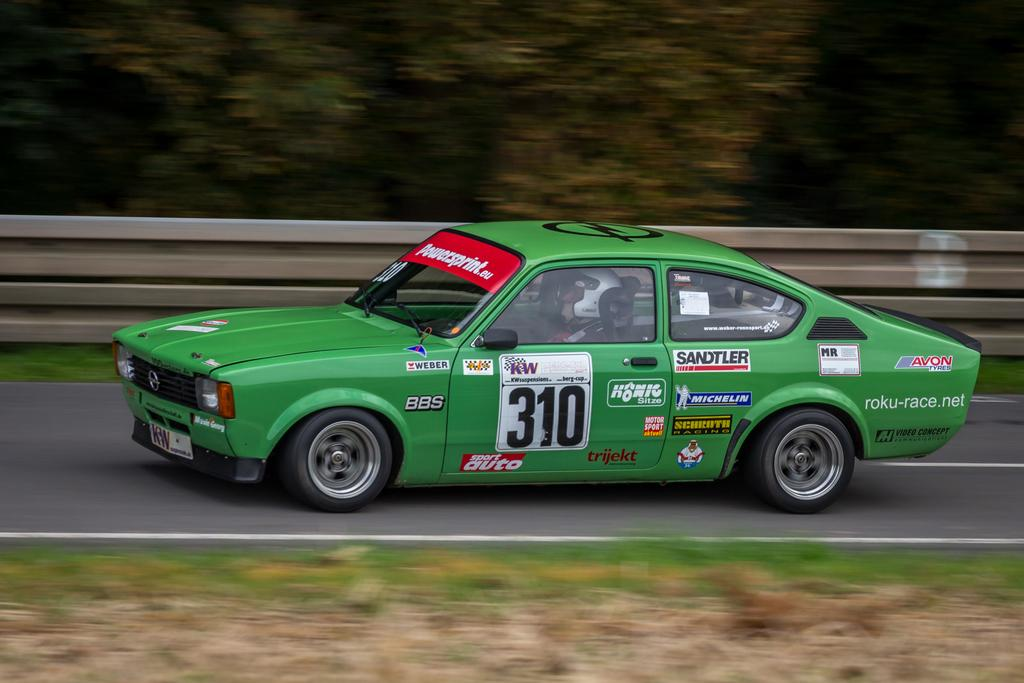What color is the car in the image? The car in the image is green. What is the car doing in the image? The car is traveling on the road. What type of vegetation is visible at the bottom of the image? There is grass at the bottom of the image. What can be seen in the background of the image? There are trees in the background of the image. Who is inside the car in the image? There is a person sitting in the car. What day of the week is it in the image? The day of the week is not mentioned or visible in the image. Is there a beggar asking for money near the car in the image? There is no beggar present in the image. 